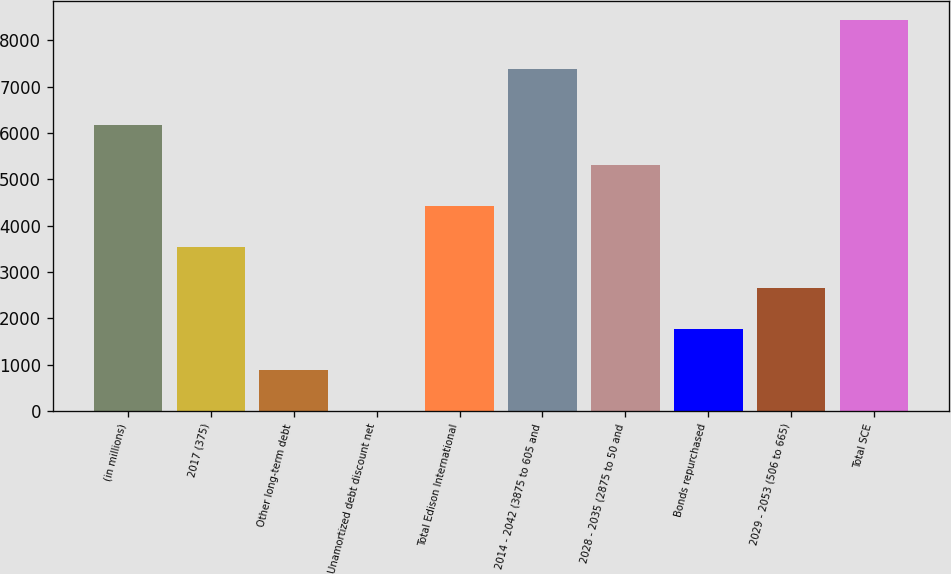Convert chart to OTSL. <chart><loc_0><loc_0><loc_500><loc_500><bar_chart><fcel>(in millions)<fcel>2017 (375)<fcel>Other long-term debt<fcel>Unamortized debt discount net<fcel>Total Edison International<fcel>2014 - 2042 (3875 to 605 and<fcel>2028 - 2035 (2875 to 50 and<fcel>Bonds repurchased<fcel>2029 - 2053 (506 to 665)<fcel>Total SCE<nl><fcel>6184.1<fcel>3534.2<fcel>884.3<fcel>1<fcel>4417.5<fcel>7375<fcel>5300.8<fcel>1767.6<fcel>2650.9<fcel>8431<nl></chart> 